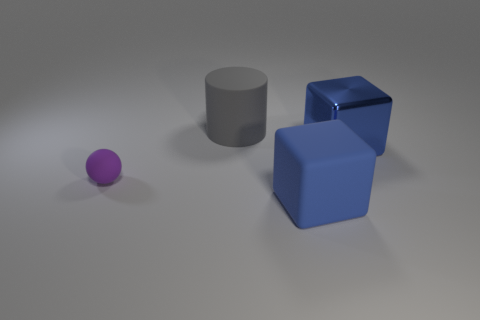Add 1 shiny cubes. How many objects exist? 5 Subtract all cylinders. How many objects are left? 3 Add 4 blue shiny blocks. How many blue shiny blocks are left? 5 Add 2 big blue metallic objects. How many big blue metallic objects exist? 3 Subtract 0 blue cylinders. How many objects are left? 4 Subtract all large cyan metallic objects. Subtract all blue blocks. How many objects are left? 2 